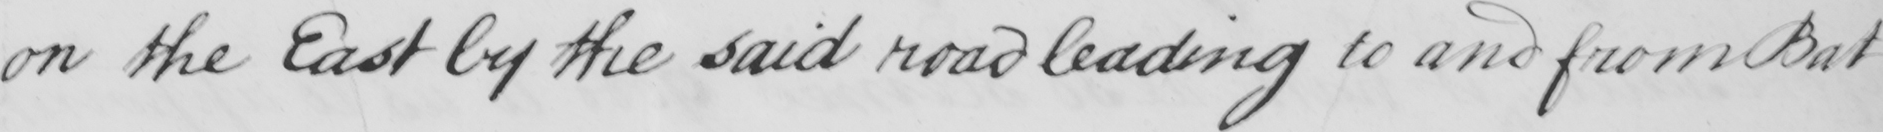Please transcribe the handwritten text in this image. on the East by the said road leading to and from Battersea , 